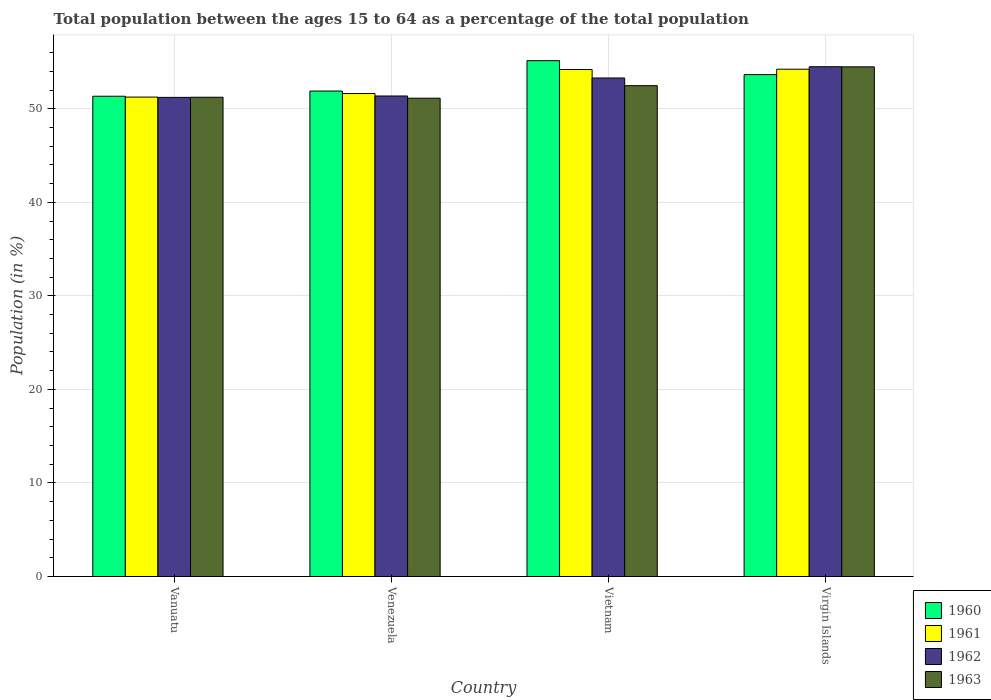How many groups of bars are there?
Provide a short and direct response. 4. Are the number of bars per tick equal to the number of legend labels?
Give a very brief answer. Yes. Are the number of bars on each tick of the X-axis equal?
Give a very brief answer. Yes. How many bars are there on the 3rd tick from the left?
Give a very brief answer. 4. How many bars are there on the 3rd tick from the right?
Provide a short and direct response. 4. What is the label of the 4th group of bars from the left?
Provide a succinct answer. Virgin Islands. What is the percentage of the population ages 15 to 64 in 1960 in Virgin Islands?
Provide a succinct answer. 53.65. Across all countries, what is the maximum percentage of the population ages 15 to 64 in 1960?
Your response must be concise. 55.14. Across all countries, what is the minimum percentage of the population ages 15 to 64 in 1960?
Your answer should be very brief. 51.34. In which country was the percentage of the population ages 15 to 64 in 1962 maximum?
Ensure brevity in your answer.  Virgin Islands. In which country was the percentage of the population ages 15 to 64 in 1961 minimum?
Your answer should be very brief. Vanuatu. What is the total percentage of the population ages 15 to 64 in 1961 in the graph?
Offer a terse response. 211.3. What is the difference between the percentage of the population ages 15 to 64 in 1962 in Vietnam and that in Virgin Islands?
Provide a succinct answer. -1.21. What is the difference between the percentage of the population ages 15 to 64 in 1960 in Vanuatu and the percentage of the population ages 15 to 64 in 1962 in Virgin Islands?
Your answer should be compact. -3.16. What is the average percentage of the population ages 15 to 64 in 1961 per country?
Ensure brevity in your answer.  52.83. What is the difference between the percentage of the population ages 15 to 64 of/in 1963 and percentage of the population ages 15 to 64 of/in 1962 in Vietnam?
Make the answer very short. -0.82. What is the ratio of the percentage of the population ages 15 to 64 in 1962 in Vietnam to that in Virgin Islands?
Keep it short and to the point. 0.98. What is the difference between the highest and the second highest percentage of the population ages 15 to 64 in 1963?
Give a very brief answer. -1.24. What is the difference between the highest and the lowest percentage of the population ages 15 to 64 in 1962?
Offer a very short reply. 3.28. Is it the case that in every country, the sum of the percentage of the population ages 15 to 64 in 1962 and percentage of the population ages 15 to 64 in 1963 is greater than the sum of percentage of the population ages 15 to 64 in 1961 and percentage of the population ages 15 to 64 in 1960?
Your response must be concise. No. What does the 2nd bar from the left in Venezuela represents?
Give a very brief answer. 1961. What does the 4th bar from the right in Venezuela represents?
Your answer should be very brief. 1960. What is the difference between two consecutive major ticks on the Y-axis?
Your answer should be very brief. 10. Are the values on the major ticks of Y-axis written in scientific E-notation?
Keep it short and to the point. No. Does the graph contain any zero values?
Your response must be concise. No. Does the graph contain grids?
Offer a terse response. Yes. How many legend labels are there?
Your answer should be very brief. 4. How are the legend labels stacked?
Your answer should be compact. Vertical. What is the title of the graph?
Provide a succinct answer. Total population between the ages 15 to 64 as a percentage of the total population. Does "1984" appear as one of the legend labels in the graph?
Provide a short and direct response. No. What is the Population (in %) of 1960 in Vanuatu?
Provide a short and direct response. 51.34. What is the Population (in %) in 1961 in Vanuatu?
Your answer should be very brief. 51.25. What is the Population (in %) in 1962 in Vanuatu?
Make the answer very short. 51.22. What is the Population (in %) of 1963 in Vanuatu?
Offer a very short reply. 51.23. What is the Population (in %) of 1960 in Venezuela?
Your answer should be very brief. 51.9. What is the Population (in %) of 1961 in Venezuela?
Offer a terse response. 51.63. What is the Population (in %) of 1962 in Venezuela?
Keep it short and to the point. 51.37. What is the Population (in %) of 1963 in Venezuela?
Keep it short and to the point. 51.13. What is the Population (in %) of 1960 in Vietnam?
Your answer should be very brief. 55.14. What is the Population (in %) in 1961 in Vietnam?
Your answer should be very brief. 54.2. What is the Population (in %) of 1962 in Vietnam?
Make the answer very short. 53.29. What is the Population (in %) of 1963 in Vietnam?
Keep it short and to the point. 52.47. What is the Population (in %) in 1960 in Virgin Islands?
Your answer should be very brief. 53.65. What is the Population (in %) in 1961 in Virgin Islands?
Your answer should be compact. 54.23. What is the Population (in %) in 1962 in Virgin Islands?
Your answer should be very brief. 54.5. What is the Population (in %) of 1963 in Virgin Islands?
Provide a succinct answer. 54.48. Across all countries, what is the maximum Population (in %) in 1960?
Provide a short and direct response. 55.14. Across all countries, what is the maximum Population (in %) in 1961?
Provide a short and direct response. 54.23. Across all countries, what is the maximum Population (in %) of 1962?
Offer a terse response. 54.5. Across all countries, what is the maximum Population (in %) of 1963?
Provide a succinct answer. 54.48. Across all countries, what is the minimum Population (in %) in 1960?
Your response must be concise. 51.34. Across all countries, what is the minimum Population (in %) of 1961?
Ensure brevity in your answer.  51.25. Across all countries, what is the minimum Population (in %) of 1962?
Offer a very short reply. 51.22. Across all countries, what is the minimum Population (in %) in 1963?
Offer a terse response. 51.13. What is the total Population (in %) of 1960 in the graph?
Provide a succinct answer. 212.03. What is the total Population (in %) of 1961 in the graph?
Offer a terse response. 211.3. What is the total Population (in %) of 1962 in the graph?
Give a very brief answer. 210.37. What is the total Population (in %) of 1963 in the graph?
Your answer should be very brief. 209.32. What is the difference between the Population (in %) in 1960 in Vanuatu and that in Venezuela?
Provide a short and direct response. -0.56. What is the difference between the Population (in %) in 1961 in Vanuatu and that in Venezuela?
Give a very brief answer. -0.38. What is the difference between the Population (in %) in 1962 in Vanuatu and that in Venezuela?
Ensure brevity in your answer.  -0.15. What is the difference between the Population (in %) in 1963 in Vanuatu and that in Venezuela?
Provide a short and direct response. 0.1. What is the difference between the Population (in %) of 1960 in Vanuatu and that in Vietnam?
Ensure brevity in your answer.  -3.8. What is the difference between the Population (in %) of 1961 in Vanuatu and that in Vietnam?
Offer a very short reply. -2.95. What is the difference between the Population (in %) in 1962 in Vanuatu and that in Vietnam?
Your answer should be compact. -2.07. What is the difference between the Population (in %) of 1963 in Vanuatu and that in Vietnam?
Your answer should be very brief. -1.24. What is the difference between the Population (in %) in 1960 in Vanuatu and that in Virgin Islands?
Provide a succinct answer. -2.31. What is the difference between the Population (in %) in 1961 in Vanuatu and that in Virgin Islands?
Keep it short and to the point. -2.98. What is the difference between the Population (in %) in 1962 in Vanuatu and that in Virgin Islands?
Ensure brevity in your answer.  -3.28. What is the difference between the Population (in %) in 1963 in Vanuatu and that in Virgin Islands?
Provide a short and direct response. -3.25. What is the difference between the Population (in %) of 1960 in Venezuela and that in Vietnam?
Ensure brevity in your answer.  -3.25. What is the difference between the Population (in %) of 1961 in Venezuela and that in Vietnam?
Offer a very short reply. -2.57. What is the difference between the Population (in %) of 1962 in Venezuela and that in Vietnam?
Your answer should be compact. -1.92. What is the difference between the Population (in %) of 1963 in Venezuela and that in Vietnam?
Ensure brevity in your answer.  -1.34. What is the difference between the Population (in %) of 1960 in Venezuela and that in Virgin Islands?
Give a very brief answer. -1.76. What is the difference between the Population (in %) of 1961 in Venezuela and that in Virgin Islands?
Your answer should be compact. -2.6. What is the difference between the Population (in %) of 1962 in Venezuela and that in Virgin Islands?
Offer a very short reply. -3.13. What is the difference between the Population (in %) of 1963 in Venezuela and that in Virgin Islands?
Keep it short and to the point. -3.35. What is the difference between the Population (in %) of 1960 in Vietnam and that in Virgin Islands?
Make the answer very short. 1.49. What is the difference between the Population (in %) of 1961 in Vietnam and that in Virgin Islands?
Give a very brief answer. -0.03. What is the difference between the Population (in %) in 1962 in Vietnam and that in Virgin Islands?
Your response must be concise. -1.21. What is the difference between the Population (in %) of 1963 in Vietnam and that in Virgin Islands?
Provide a succinct answer. -2.01. What is the difference between the Population (in %) of 1960 in Vanuatu and the Population (in %) of 1961 in Venezuela?
Make the answer very short. -0.29. What is the difference between the Population (in %) of 1960 in Vanuatu and the Population (in %) of 1962 in Venezuela?
Your answer should be compact. -0.03. What is the difference between the Population (in %) of 1960 in Vanuatu and the Population (in %) of 1963 in Venezuela?
Make the answer very short. 0.21. What is the difference between the Population (in %) of 1961 in Vanuatu and the Population (in %) of 1962 in Venezuela?
Provide a succinct answer. -0.12. What is the difference between the Population (in %) of 1961 in Vanuatu and the Population (in %) of 1963 in Venezuela?
Give a very brief answer. 0.12. What is the difference between the Population (in %) in 1962 in Vanuatu and the Population (in %) in 1963 in Venezuela?
Offer a terse response. 0.09. What is the difference between the Population (in %) in 1960 in Vanuatu and the Population (in %) in 1961 in Vietnam?
Provide a succinct answer. -2.86. What is the difference between the Population (in %) of 1960 in Vanuatu and the Population (in %) of 1962 in Vietnam?
Provide a short and direct response. -1.95. What is the difference between the Population (in %) of 1960 in Vanuatu and the Population (in %) of 1963 in Vietnam?
Offer a terse response. -1.13. What is the difference between the Population (in %) in 1961 in Vanuatu and the Population (in %) in 1962 in Vietnam?
Offer a very short reply. -2.04. What is the difference between the Population (in %) of 1961 in Vanuatu and the Population (in %) of 1963 in Vietnam?
Offer a very short reply. -1.22. What is the difference between the Population (in %) of 1962 in Vanuatu and the Population (in %) of 1963 in Vietnam?
Your answer should be compact. -1.25. What is the difference between the Population (in %) in 1960 in Vanuatu and the Population (in %) in 1961 in Virgin Islands?
Make the answer very short. -2.89. What is the difference between the Population (in %) of 1960 in Vanuatu and the Population (in %) of 1962 in Virgin Islands?
Make the answer very short. -3.16. What is the difference between the Population (in %) in 1960 in Vanuatu and the Population (in %) in 1963 in Virgin Islands?
Your answer should be compact. -3.14. What is the difference between the Population (in %) in 1961 in Vanuatu and the Population (in %) in 1962 in Virgin Islands?
Offer a very short reply. -3.25. What is the difference between the Population (in %) of 1961 in Vanuatu and the Population (in %) of 1963 in Virgin Islands?
Your answer should be very brief. -3.23. What is the difference between the Population (in %) in 1962 in Vanuatu and the Population (in %) in 1963 in Virgin Islands?
Your response must be concise. -3.27. What is the difference between the Population (in %) in 1960 in Venezuela and the Population (in %) in 1961 in Vietnam?
Your response must be concise. -2.3. What is the difference between the Population (in %) of 1960 in Venezuela and the Population (in %) of 1962 in Vietnam?
Keep it short and to the point. -1.4. What is the difference between the Population (in %) in 1960 in Venezuela and the Population (in %) in 1963 in Vietnam?
Make the answer very short. -0.57. What is the difference between the Population (in %) in 1961 in Venezuela and the Population (in %) in 1962 in Vietnam?
Your answer should be compact. -1.66. What is the difference between the Population (in %) of 1961 in Venezuela and the Population (in %) of 1963 in Vietnam?
Provide a short and direct response. -0.84. What is the difference between the Population (in %) of 1962 in Venezuela and the Population (in %) of 1963 in Vietnam?
Give a very brief answer. -1.1. What is the difference between the Population (in %) of 1960 in Venezuela and the Population (in %) of 1961 in Virgin Islands?
Offer a very short reply. -2.33. What is the difference between the Population (in %) of 1960 in Venezuela and the Population (in %) of 1962 in Virgin Islands?
Provide a succinct answer. -2.6. What is the difference between the Population (in %) of 1960 in Venezuela and the Population (in %) of 1963 in Virgin Islands?
Your response must be concise. -2.59. What is the difference between the Population (in %) of 1961 in Venezuela and the Population (in %) of 1962 in Virgin Islands?
Provide a succinct answer. -2.87. What is the difference between the Population (in %) of 1961 in Venezuela and the Population (in %) of 1963 in Virgin Islands?
Offer a terse response. -2.85. What is the difference between the Population (in %) of 1962 in Venezuela and the Population (in %) of 1963 in Virgin Islands?
Offer a very short reply. -3.12. What is the difference between the Population (in %) in 1960 in Vietnam and the Population (in %) in 1961 in Virgin Islands?
Give a very brief answer. 0.91. What is the difference between the Population (in %) of 1960 in Vietnam and the Population (in %) of 1962 in Virgin Islands?
Your answer should be compact. 0.65. What is the difference between the Population (in %) of 1960 in Vietnam and the Population (in %) of 1963 in Virgin Islands?
Make the answer very short. 0.66. What is the difference between the Population (in %) in 1961 in Vietnam and the Population (in %) in 1962 in Virgin Islands?
Provide a succinct answer. -0.3. What is the difference between the Population (in %) of 1961 in Vietnam and the Population (in %) of 1963 in Virgin Islands?
Keep it short and to the point. -0.29. What is the difference between the Population (in %) in 1962 in Vietnam and the Population (in %) in 1963 in Virgin Islands?
Ensure brevity in your answer.  -1.19. What is the average Population (in %) of 1960 per country?
Provide a succinct answer. 53.01. What is the average Population (in %) in 1961 per country?
Provide a short and direct response. 52.83. What is the average Population (in %) in 1962 per country?
Provide a short and direct response. 52.59. What is the average Population (in %) in 1963 per country?
Ensure brevity in your answer.  52.33. What is the difference between the Population (in %) of 1960 and Population (in %) of 1961 in Vanuatu?
Ensure brevity in your answer.  0.09. What is the difference between the Population (in %) in 1960 and Population (in %) in 1962 in Vanuatu?
Offer a terse response. 0.12. What is the difference between the Population (in %) in 1960 and Population (in %) in 1963 in Vanuatu?
Your response must be concise. 0.11. What is the difference between the Population (in %) in 1961 and Population (in %) in 1962 in Vanuatu?
Keep it short and to the point. 0.03. What is the difference between the Population (in %) in 1961 and Population (in %) in 1963 in Vanuatu?
Your answer should be very brief. 0.02. What is the difference between the Population (in %) of 1962 and Population (in %) of 1963 in Vanuatu?
Your answer should be very brief. -0.02. What is the difference between the Population (in %) of 1960 and Population (in %) of 1961 in Venezuela?
Your response must be concise. 0.27. What is the difference between the Population (in %) in 1960 and Population (in %) in 1962 in Venezuela?
Your answer should be very brief. 0.53. What is the difference between the Population (in %) of 1960 and Population (in %) of 1963 in Venezuela?
Provide a succinct answer. 0.76. What is the difference between the Population (in %) in 1961 and Population (in %) in 1962 in Venezuela?
Provide a short and direct response. 0.26. What is the difference between the Population (in %) in 1961 and Population (in %) in 1963 in Venezuela?
Your response must be concise. 0.5. What is the difference between the Population (in %) in 1962 and Population (in %) in 1963 in Venezuela?
Provide a succinct answer. 0.24. What is the difference between the Population (in %) in 1960 and Population (in %) in 1961 in Vietnam?
Provide a succinct answer. 0.95. What is the difference between the Population (in %) of 1960 and Population (in %) of 1962 in Vietnam?
Your answer should be compact. 1.85. What is the difference between the Population (in %) in 1960 and Population (in %) in 1963 in Vietnam?
Provide a succinct answer. 2.67. What is the difference between the Population (in %) of 1961 and Population (in %) of 1962 in Vietnam?
Give a very brief answer. 0.91. What is the difference between the Population (in %) of 1961 and Population (in %) of 1963 in Vietnam?
Offer a very short reply. 1.73. What is the difference between the Population (in %) in 1962 and Population (in %) in 1963 in Vietnam?
Offer a very short reply. 0.82. What is the difference between the Population (in %) of 1960 and Population (in %) of 1961 in Virgin Islands?
Offer a terse response. -0.58. What is the difference between the Population (in %) in 1960 and Population (in %) in 1962 in Virgin Islands?
Provide a succinct answer. -0.84. What is the difference between the Population (in %) in 1960 and Population (in %) in 1963 in Virgin Islands?
Your response must be concise. -0.83. What is the difference between the Population (in %) in 1961 and Population (in %) in 1962 in Virgin Islands?
Your answer should be very brief. -0.27. What is the difference between the Population (in %) of 1961 and Population (in %) of 1963 in Virgin Islands?
Ensure brevity in your answer.  -0.25. What is the difference between the Population (in %) in 1962 and Population (in %) in 1963 in Virgin Islands?
Provide a succinct answer. 0.01. What is the ratio of the Population (in %) in 1960 in Vanuatu to that in Venezuela?
Keep it short and to the point. 0.99. What is the ratio of the Population (in %) of 1962 in Vanuatu to that in Venezuela?
Your response must be concise. 1. What is the ratio of the Population (in %) of 1961 in Vanuatu to that in Vietnam?
Give a very brief answer. 0.95. What is the ratio of the Population (in %) in 1962 in Vanuatu to that in Vietnam?
Ensure brevity in your answer.  0.96. What is the ratio of the Population (in %) of 1963 in Vanuatu to that in Vietnam?
Offer a very short reply. 0.98. What is the ratio of the Population (in %) in 1960 in Vanuatu to that in Virgin Islands?
Offer a terse response. 0.96. What is the ratio of the Population (in %) in 1961 in Vanuatu to that in Virgin Islands?
Offer a very short reply. 0.94. What is the ratio of the Population (in %) in 1962 in Vanuatu to that in Virgin Islands?
Your response must be concise. 0.94. What is the ratio of the Population (in %) of 1963 in Vanuatu to that in Virgin Islands?
Provide a short and direct response. 0.94. What is the ratio of the Population (in %) of 1960 in Venezuela to that in Vietnam?
Your response must be concise. 0.94. What is the ratio of the Population (in %) of 1961 in Venezuela to that in Vietnam?
Offer a very short reply. 0.95. What is the ratio of the Population (in %) of 1962 in Venezuela to that in Vietnam?
Offer a very short reply. 0.96. What is the ratio of the Population (in %) of 1963 in Venezuela to that in Vietnam?
Keep it short and to the point. 0.97. What is the ratio of the Population (in %) in 1960 in Venezuela to that in Virgin Islands?
Your response must be concise. 0.97. What is the ratio of the Population (in %) in 1961 in Venezuela to that in Virgin Islands?
Your response must be concise. 0.95. What is the ratio of the Population (in %) of 1962 in Venezuela to that in Virgin Islands?
Offer a very short reply. 0.94. What is the ratio of the Population (in %) in 1963 in Venezuela to that in Virgin Islands?
Offer a terse response. 0.94. What is the ratio of the Population (in %) in 1960 in Vietnam to that in Virgin Islands?
Provide a short and direct response. 1.03. What is the ratio of the Population (in %) of 1961 in Vietnam to that in Virgin Islands?
Provide a short and direct response. 1. What is the ratio of the Population (in %) in 1962 in Vietnam to that in Virgin Islands?
Provide a short and direct response. 0.98. What is the ratio of the Population (in %) of 1963 in Vietnam to that in Virgin Islands?
Offer a terse response. 0.96. What is the difference between the highest and the second highest Population (in %) in 1960?
Provide a short and direct response. 1.49. What is the difference between the highest and the second highest Population (in %) in 1961?
Provide a short and direct response. 0.03. What is the difference between the highest and the second highest Population (in %) in 1962?
Make the answer very short. 1.21. What is the difference between the highest and the second highest Population (in %) of 1963?
Ensure brevity in your answer.  2.01. What is the difference between the highest and the lowest Population (in %) in 1960?
Provide a short and direct response. 3.8. What is the difference between the highest and the lowest Population (in %) of 1961?
Give a very brief answer. 2.98. What is the difference between the highest and the lowest Population (in %) in 1962?
Keep it short and to the point. 3.28. What is the difference between the highest and the lowest Population (in %) of 1963?
Offer a very short reply. 3.35. 